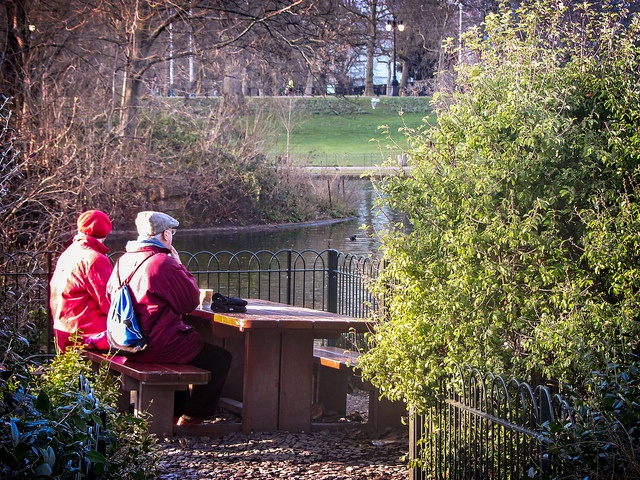Describe the objects in this image and their specific colors. I can see people in black, purple, and white tones, people in black, white, and brown tones, bench in black, maroon, brown, and purple tones, bench in black and gray tones, and dining table in black, gray, lightgray, and maroon tones in this image. 